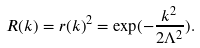<formula> <loc_0><loc_0><loc_500><loc_500>R ( k ) = r ( k ) ^ { 2 } = \exp ( - \frac { k ^ { 2 } } { 2 \Lambda ^ { 2 } } ) .</formula> 